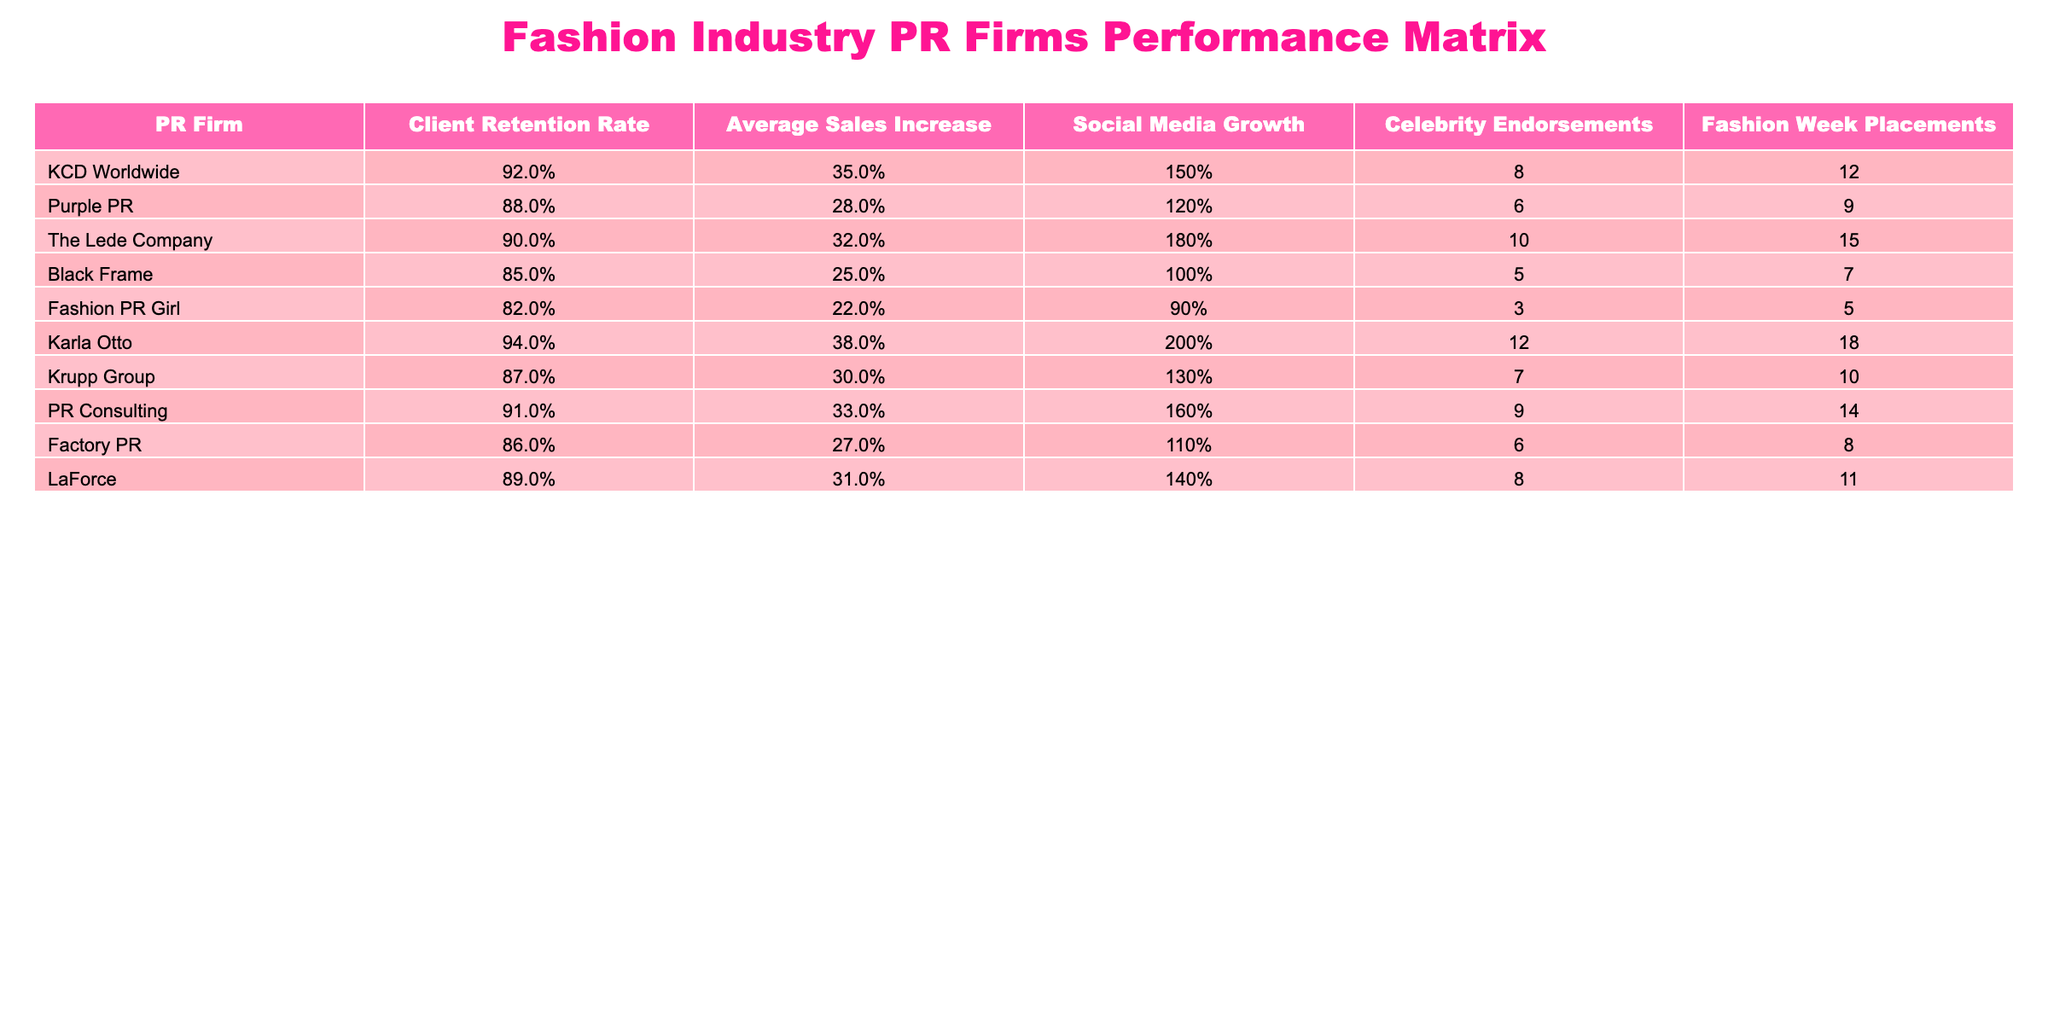What is the client retention rate of KCD Worldwide? The table shows that KCD Worldwide has a client retention rate of 92%.
Answer: 92% Which PR firm has the highest average sales increase? By comparing the 'Average Sales Increase' values, Karla Otto has the highest at 38%.
Answer: Karla Otto How many celebrity endorsements did The Lede Company secure? The table indicates that The Lede Company secured 10 celebrity endorsements.
Answer: 10 What is the social media growth percentage for Fashion PR Girl? The social media growth for Fashion PR Girl is 90%, as displayed in the corresponding column.
Answer: 90% Which PR firm has the lowest client retention rate? The lowest client retention rate in the table is for Fashion PR Girl, at 82%.
Answer: Fashion PR Girl What is the average sales increase for firms with a client retention rate above 90%? The firms above 90% are KCD Worldwide (35%), The Lede Company (32%), and Karla Otto (38%). The average is (35 + 32 + 38) / 3 = 35%.
Answer: 35% Did Purple PR have more social media growth than Factory PR? Purple PR has 120% social media growth, while Factory PR has 110%. Yes, Purple PR did have more growth.
Answer: Yes If you sum the celebrity endorsements of KCD Worldwide, Purple PR, and PR Consulting, what total do you get? The endorsements are 8 (KCD Worldwide) + 6 (Purple PR) + 9 (PR Consulting), totaling 23 endorsements.
Answer: 23 Which PR firm has the highest social media growth percentage? The highest social media growth percentage is 200%, which belongs to Karla Otto.
Answer: Karla Otto Is there any PR firm that managed to secure more than 10 placements at Fashion Week? By checking the 'Fashion Week Placements' column, we see that Karla Otto (18) and The Lede Company (15) both secured more than 10 placements.
Answer: Yes 